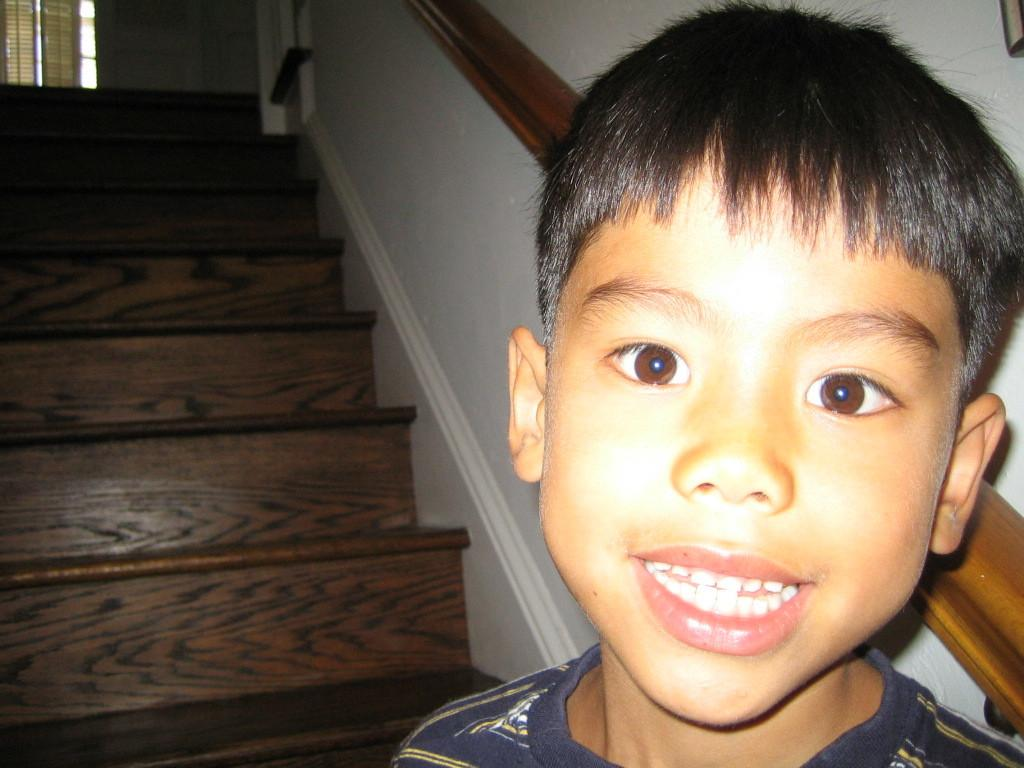Where was the image taken? The image was taken indoors. What can be seen in the background of the image? There is a wall and stairs in the background of the image. What is present near the window in the image? There is a window blind in the image. Where is the kid located in the image? The kid is on the right side of the image. What type of smoke can be seen coming from the kid's head in the image? There is no smoke present in the image, and the kid's head is not depicted as emitting any smoke. 